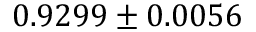Convert formula to latex. <formula><loc_0><loc_0><loc_500><loc_500>0 . 9 2 9 9 \pm 0 . 0 0 5 6</formula> 